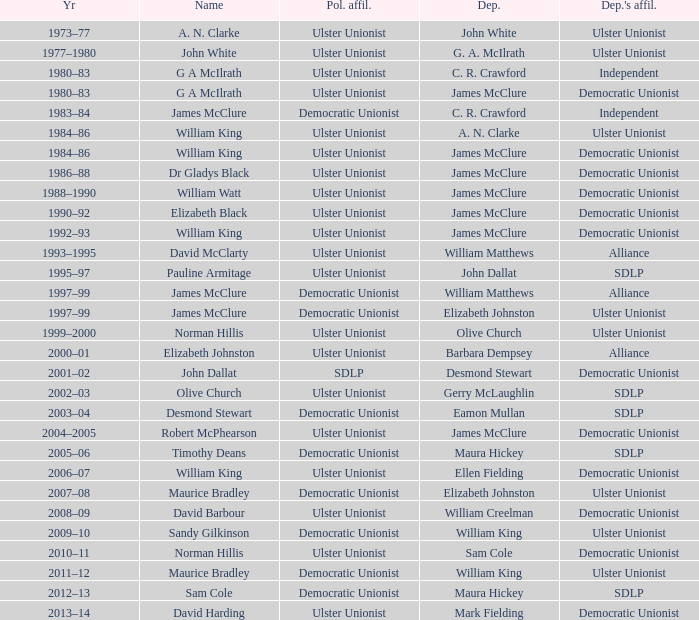What Year was james mcclure Deputy, and the Name is robert mcphearson? 2004–2005. 